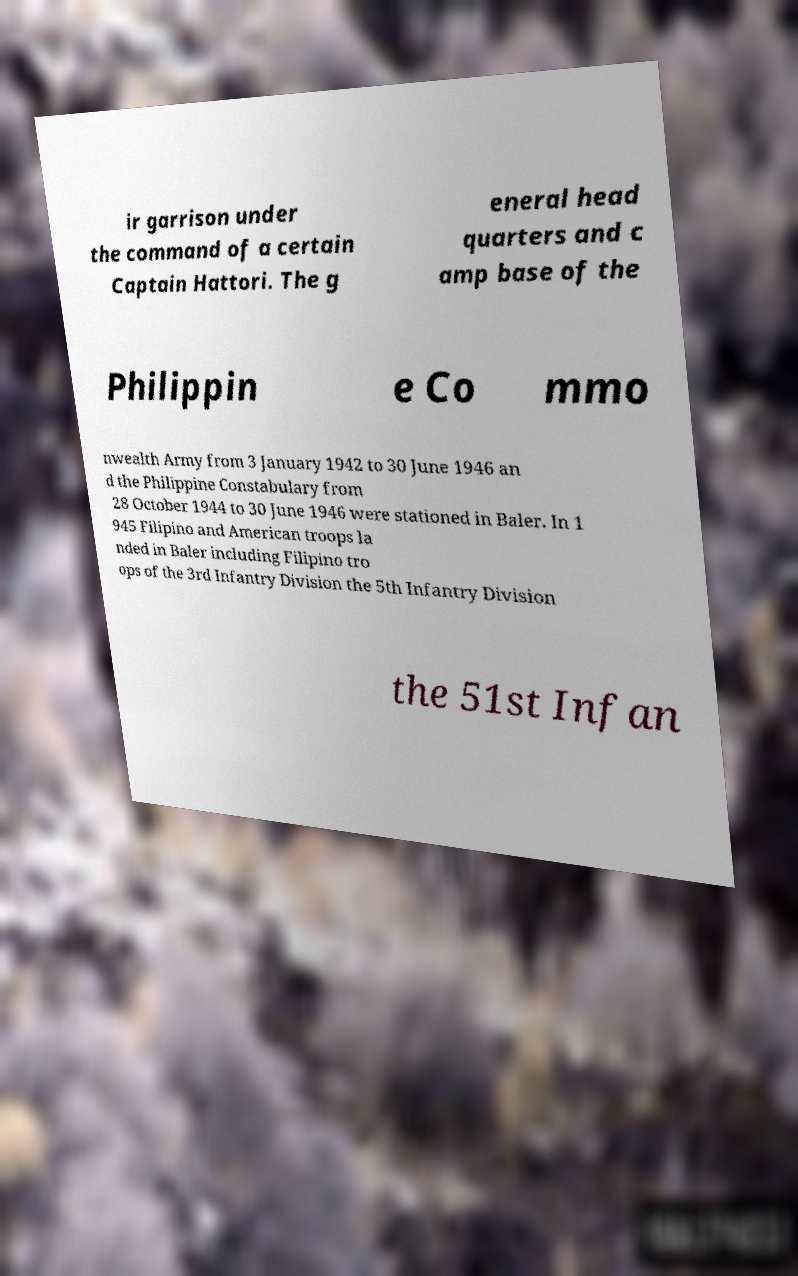There's text embedded in this image that I need extracted. Can you transcribe it verbatim? ir garrison under the command of a certain Captain Hattori. The g eneral head quarters and c amp base of the Philippin e Co mmo nwealth Army from 3 January 1942 to 30 June 1946 an d the Philippine Constabulary from 28 October 1944 to 30 June 1946 were stationed in Baler. In 1 945 Filipino and American troops la nded in Baler including Filipino tro ops of the 3rd Infantry Division the 5th Infantry Division the 51st Infan 